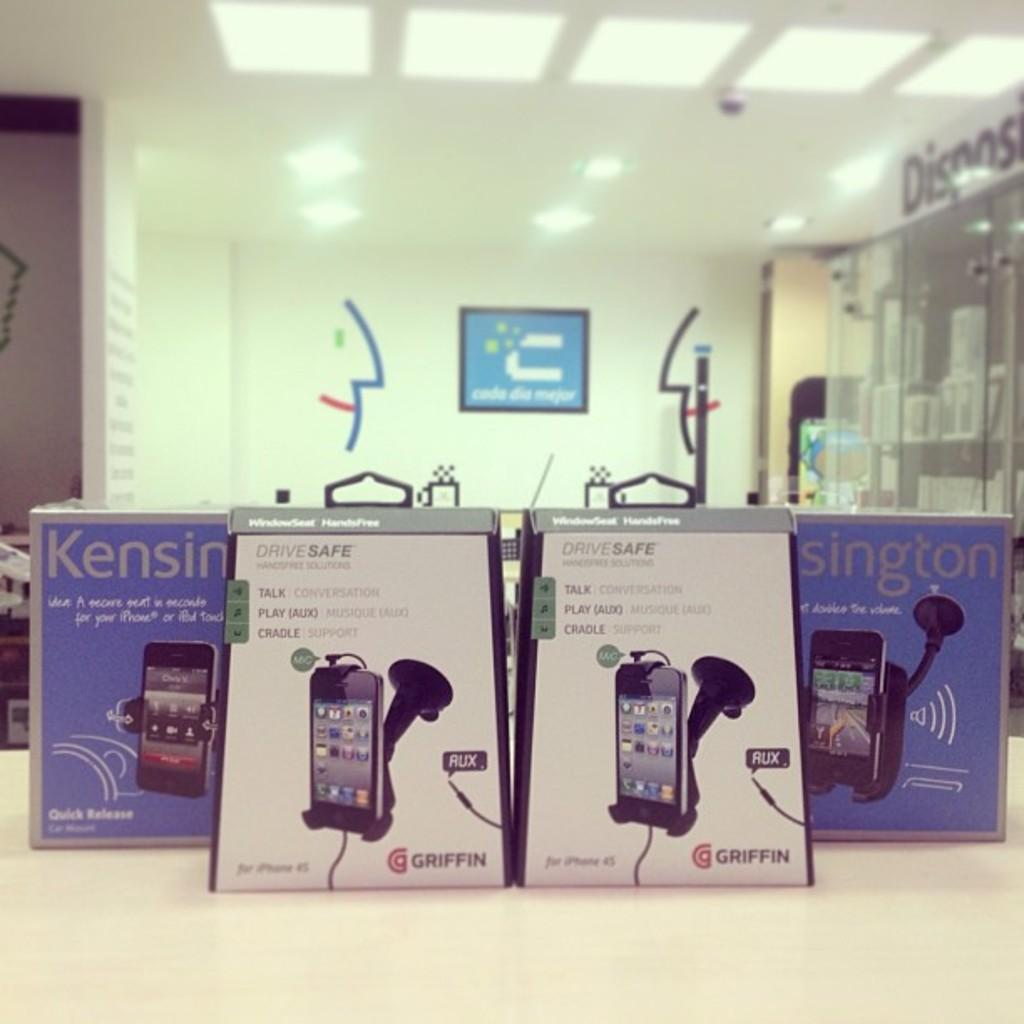<image>
Share a concise interpretation of the image provided. Two ads beside each other for Griffin brand products. 